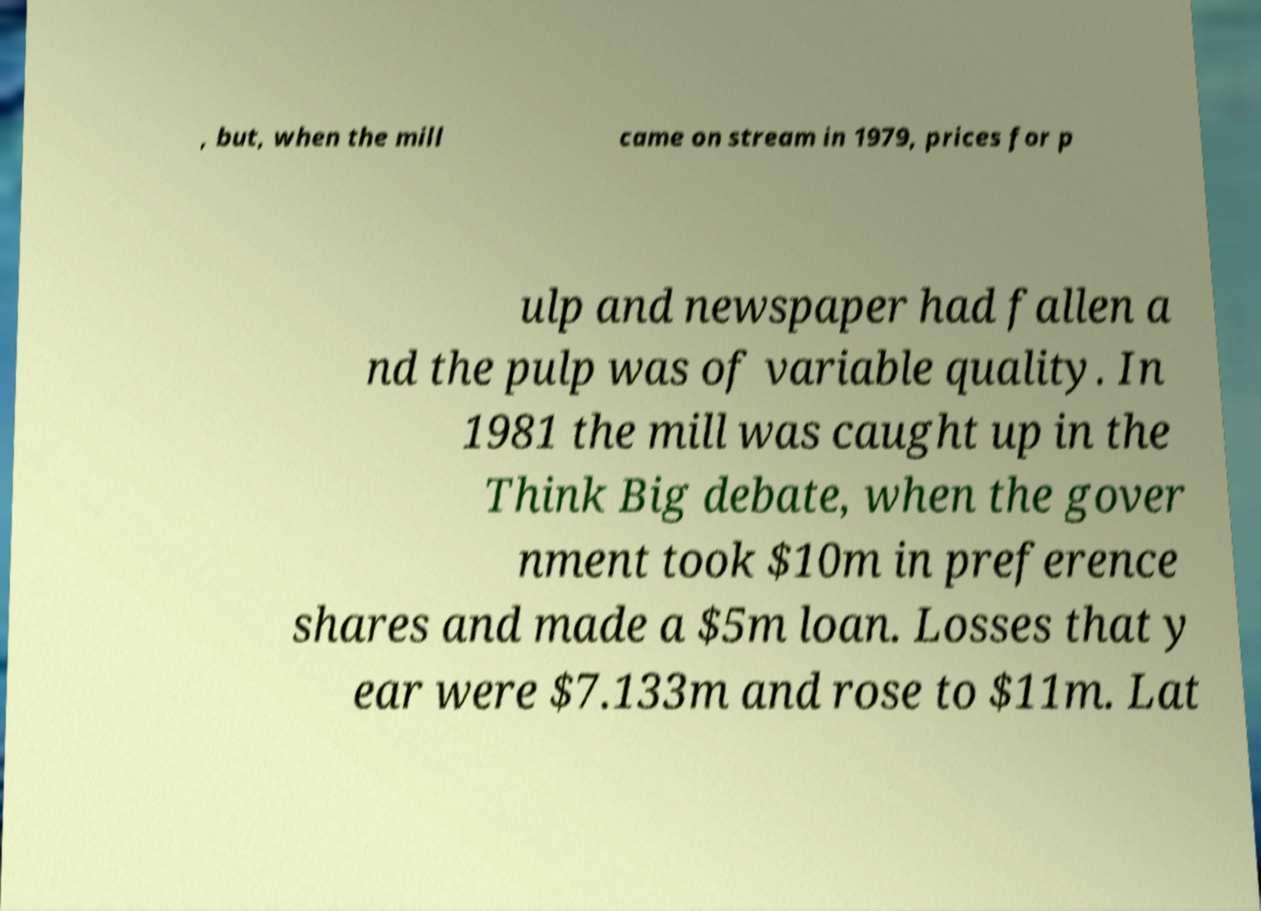Can you accurately transcribe the text from the provided image for me? , but, when the mill came on stream in 1979, prices for p ulp and newspaper had fallen a nd the pulp was of variable quality. In 1981 the mill was caught up in the Think Big debate, when the gover nment took $10m in preference shares and made a $5m loan. Losses that y ear were $7.133m and rose to $11m. Lat 